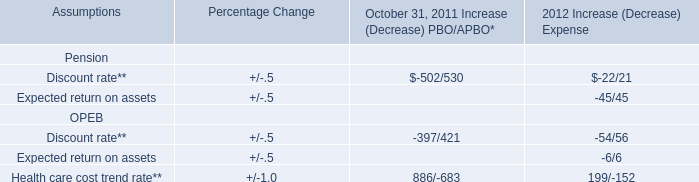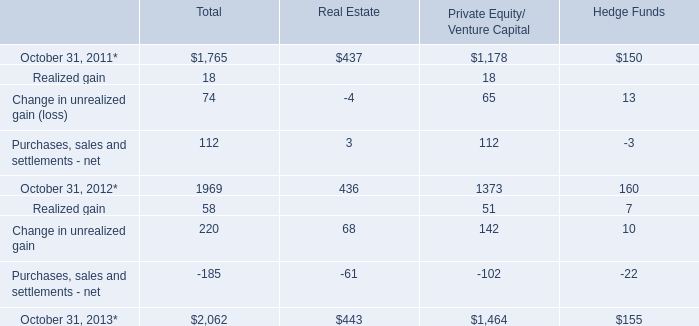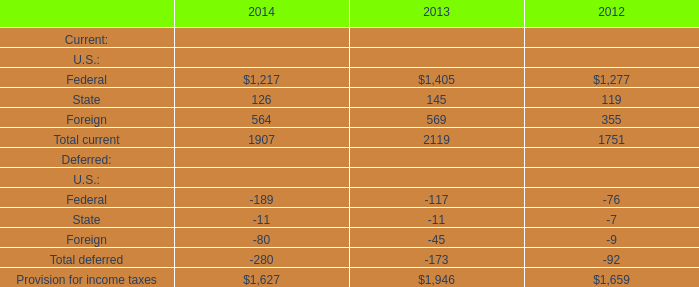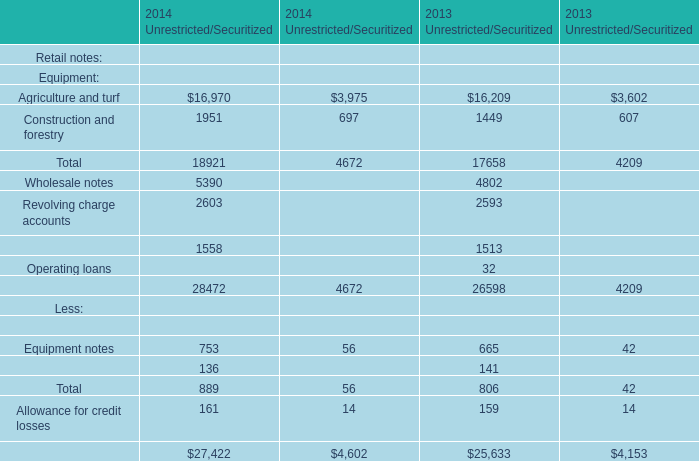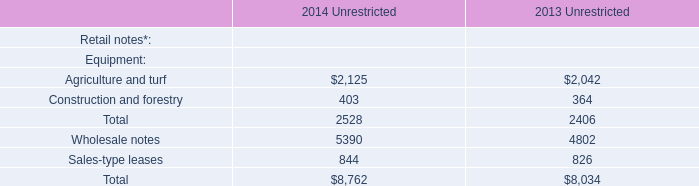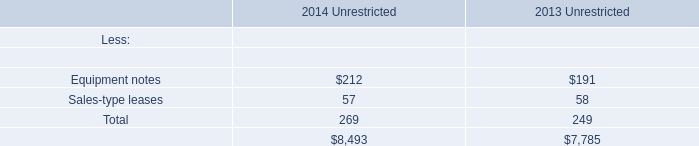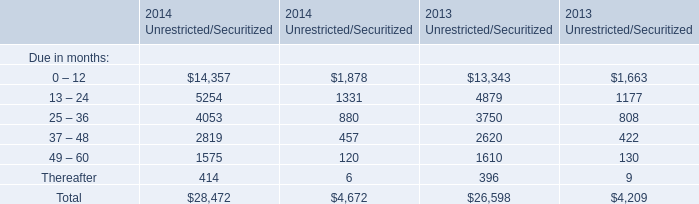How many years does Financing receivables related to the company’s sales of equipment stay higher than Sales-type leases? 
Answer: 2. 